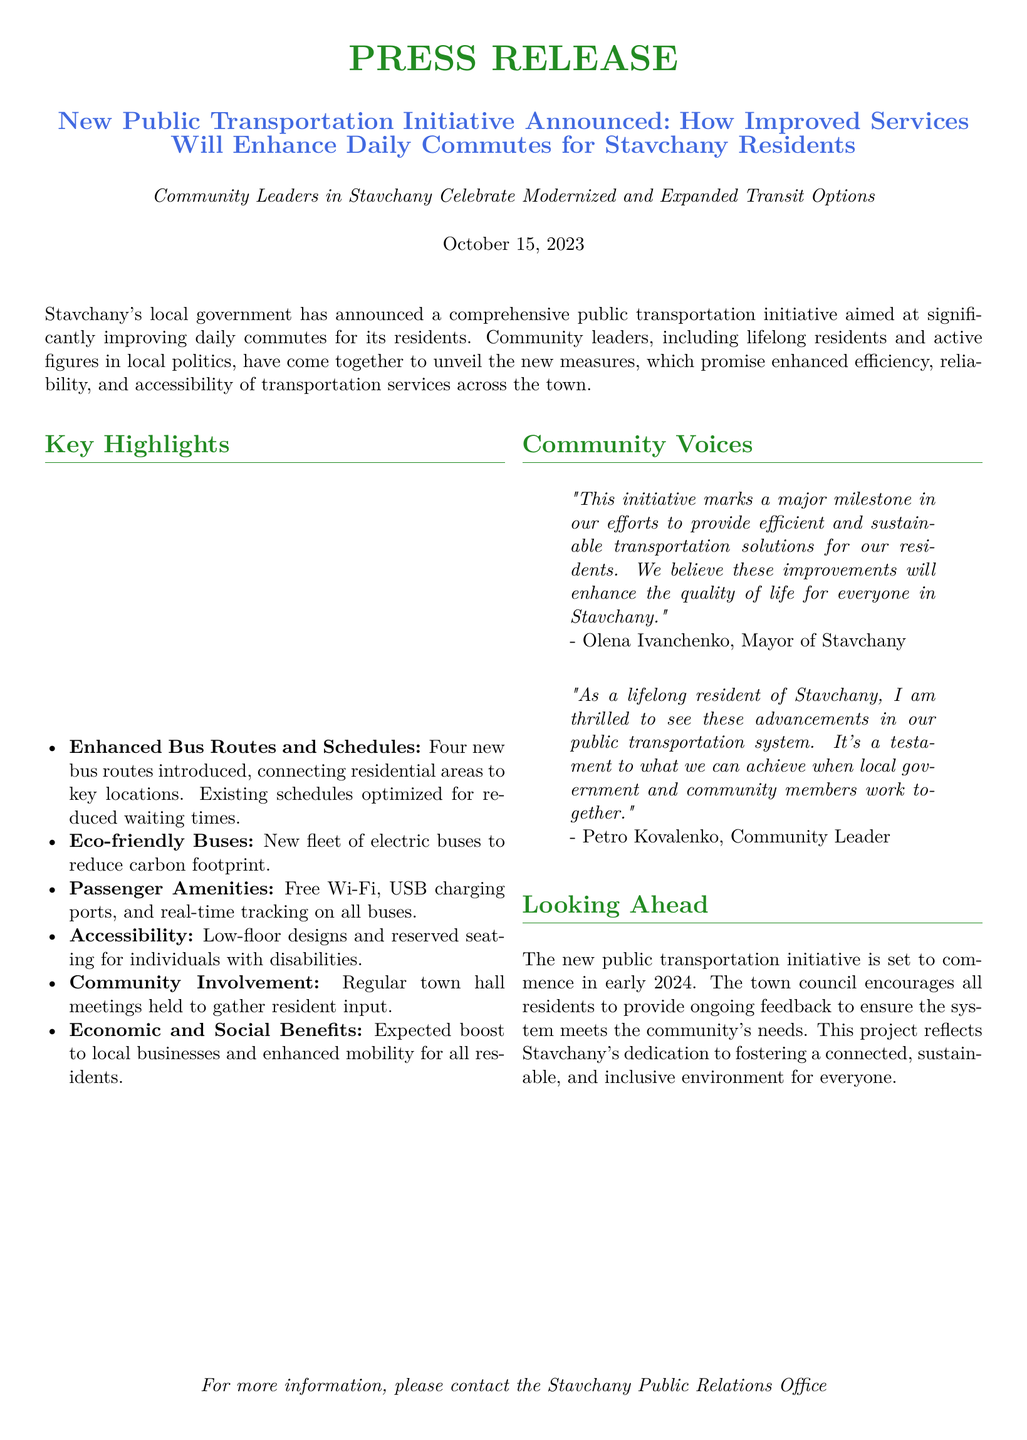What date was the announcement made? The document states that the announcement was made on October 15, 2023.
Answer: October 15, 2023 How many new bus routes will be introduced? The document mentions that four new bus routes will be introduced.
Answer: Four What type of buses will be introduced in the new fleet? It is specified in the document that the new fleet will consist of electric buses.
Answer: Electric buses Who is the Mayor of Stavchany? The document quotes Olena Ivanchenko as the Mayor of Stavchany.
Answer: Olena Ivanchenko What will the new transportation initiative enhance according to the Mayor? The Mayor states that the initiative will enhance the quality of life for everyone.
Answer: Quality of life What is the main goal of the new public transportation initiative? The main goal is to provide efficient and sustainable transportation solutions.
Answer: Efficient and sustainable transportation solutions When is the new public transportation initiative set to commence? The document indicates that the initiative is set to commence in early 2024.
Answer: Early 2024 What method will be used to gather resident input? The document mentions that regular town hall meetings will be held for this purpose.
Answer: Town hall meetings What are some passenger amenities included in the new buses? The document lists free Wi-Fi, USB charging ports, and real-time tracking as amenities.
Answer: Free Wi-Fi, USB charging ports, real-time tracking 